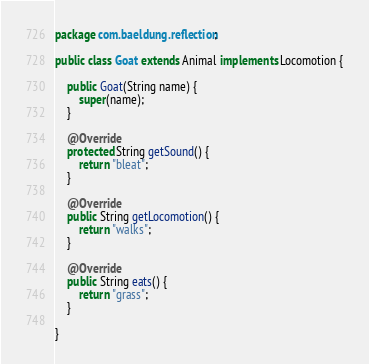Convert code to text. <code><loc_0><loc_0><loc_500><loc_500><_Java_>package com.baeldung.reflection;

public class Goat extends Animal implements Locomotion {

    public Goat(String name) {
        super(name);
    }

    @Override
    protected String getSound() {
        return "bleat";
    }

    @Override
    public String getLocomotion() {
        return "walks";
    }

    @Override
    public String eats() {
        return "grass";
    }

}
</code> 